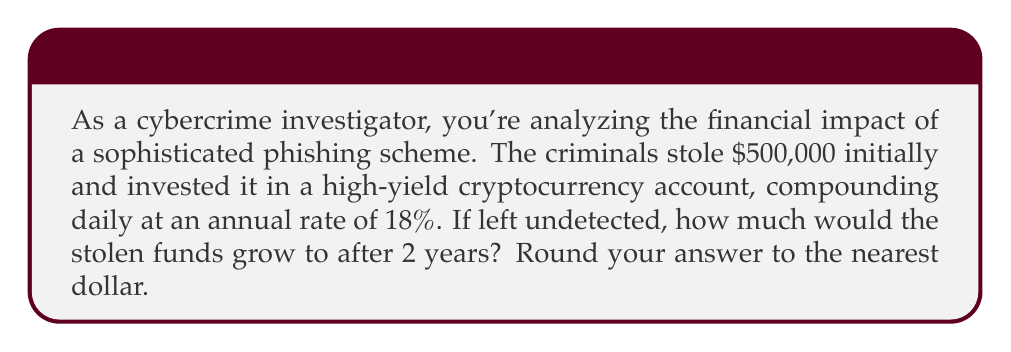Can you solve this math problem? To solve this problem, we'll use the compound interest formula:

$$A = P(1 + \frac{r}{n})^{nt}$$

Where:
$A$ = Final amount
$P$ = Principal (initial investment)
$r$ = Annual interest rate (as a decimal)
$n$ = Number of times interest is compounded per year
$t$ = Number of years

Given:
$P = \$500,000$
$r = 18\% = 0.18$
$n = 365$ (daily compounding)
$t = 2$ years

Let's substitute these values into the formula:

$$A = 500,000(1 + \frac{0.18}{365})^{365 \cdot 2}$$

Now, let's calculate step by step:

1. Simplify the fraction inside the parentheses:
   $$A = 500,000(1 + 0.000493151)^{730}$$

2. Calculate the value inside the parentheses:
   $$A = 500,000(1.000493151)^{730}$$

3. Use a calculator to compute the exponent:
   $$A = 500,000 \cdot 1.4339$$

4. Multiply:
   $$A = 716,950$$

5. Round to the nearest dollar:
   $$A = \$716,950$$
Answer: $716,950 